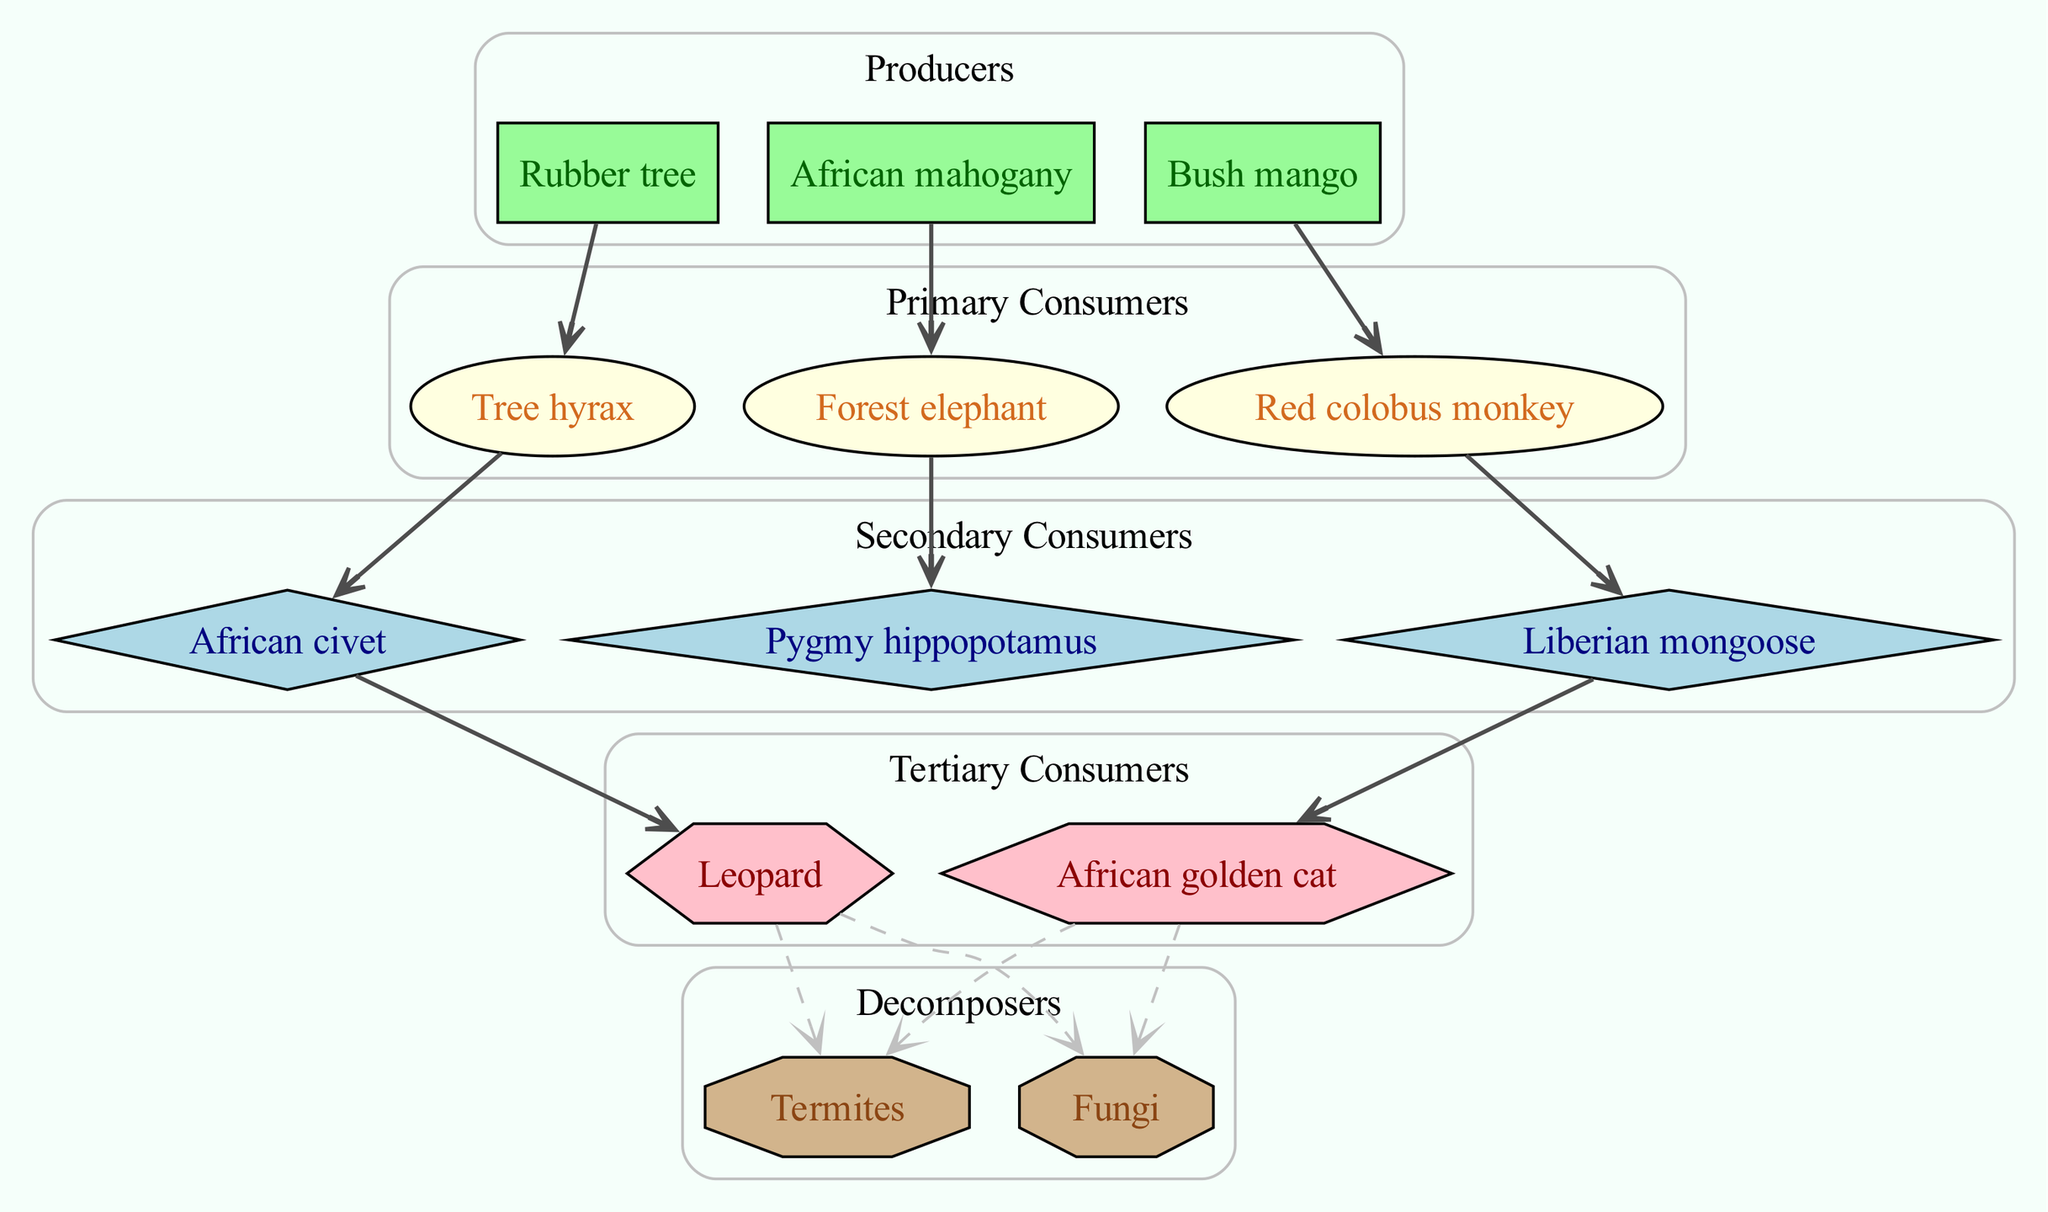What is the primary producer in this food chain? According to the diagram, the primary producers are at the top of the food chain and are identified as organisms that create energy. In this case, "Rubber tree" is listed as a primary producer among others.
Answer: Rubber tree How many primary consumers are there? The primary consumers are represented in the section below the producers. Counting the listed organisms, there are three primary consumers: "Tree hyrax", "Forest elephant", and "Red colobus monkey".
Answer: 3 Which animal is a secondary consumer that preys on the red colobus monkey? By examining the relationships, the flow indicates that the "Red colobus monkey" is directly linked to the "Liberian mongoose" as its predator. Therefore, "Liberian mongoose" is the secondary consumer that preys on it.
Answer: Liberian mongoose What type of organism is a rubber tree? The rubber tree falls under the category of producers, which are organisms that generate energy and serve as the base of the food chain in the diagram.
Answer: Producer Which tertiary consumer preys on the African civet? Based on the relationships depicted, the flow shows that the "African civet" is linked to the "Leopard", indicating that the leopard is the tertiary consumer that preys on it.
Answer: Leopard What decomposer is linked to both the leopard and the African golden cat? The diagram identifies and connects "Termites" and "Fungi" as the decomposers responsible for breaking down organic matter coming from both the "Leopard" and "African golden cat".
Answer: Termites and Fungi How many organisms are classified as secondary consumers? In the diagram, the secondary consumers include "African civet", "Liberian mongoose", and "Pygmy hippopotamus". Counting these organisms shows that there are three secondary consumers present.
Answer: 3 What is the relationship between the forest elephant and the pygmy hippopotamus? The diagram illustrates a direct relationship where the "Forest elephant" is consumed by the "Pygmy hippopotamus", as indicated in the flow of the food chain relationships section.
Answer: Forest elephant → Pygmy hippopotamus 